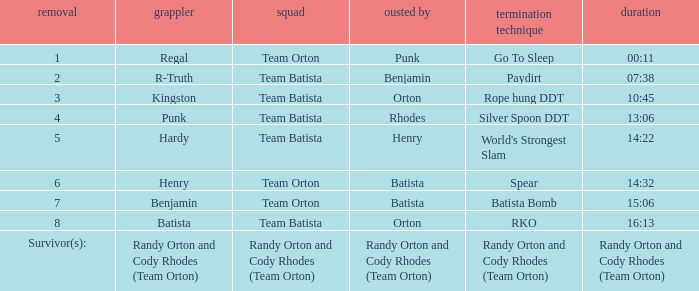Which Wrestler plays for Team Batista which was Elimated by Orton on Elimination 8? Batista. 